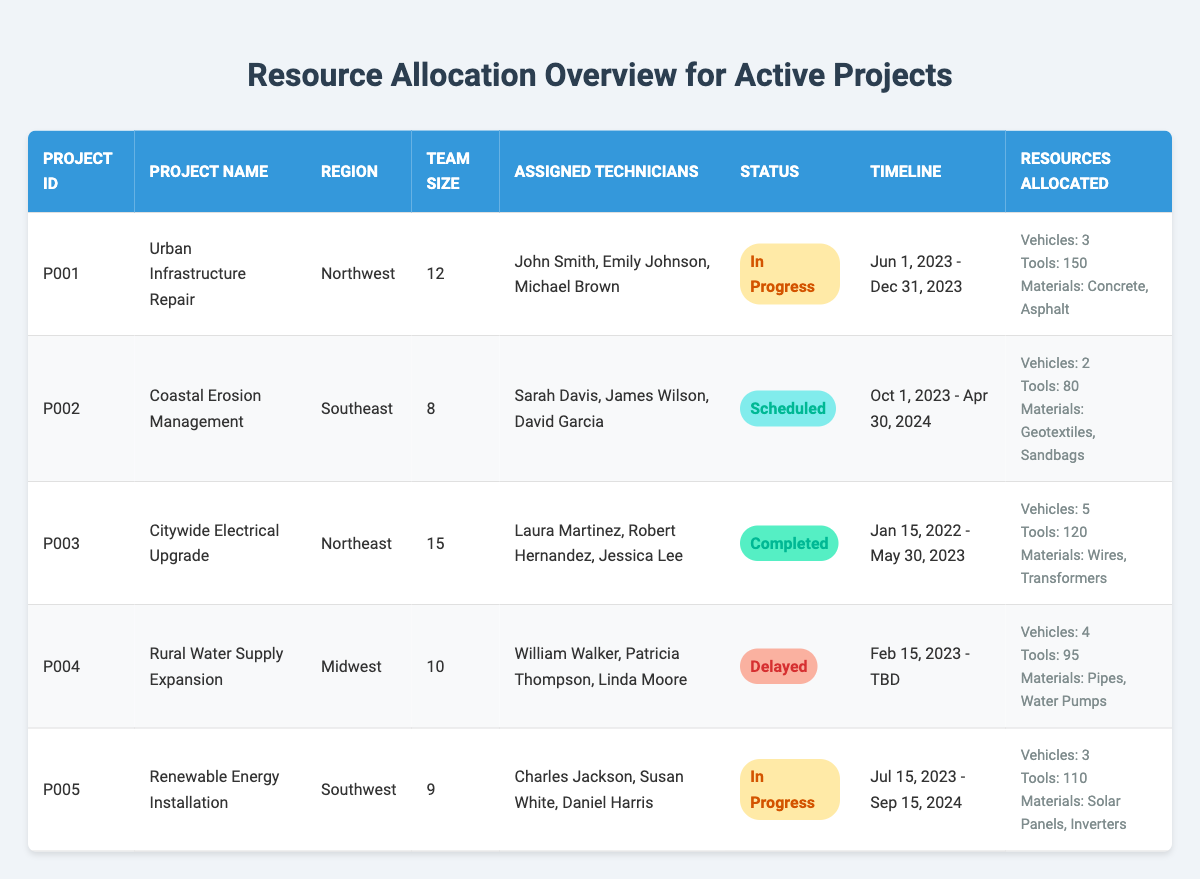What is the project name for ID P002? By looking at the table, I can find the row where the Project ID is P002, which corresponds to the project name "Coastal Erosion Management."
Answer: Coastal Erosion Management How many vehicles are allocated to the "Urban Infrastructure Repair" project? The project with the name "Urban Infrastructure Repair" has 3 vehicles allocated, as indicated in the resources allocated section of the respective row.
Answer: 3 Which project has the largest team size? To determine the largest team size, I compare the team sizes listed for all projects. The largest team size is 15, which belongs to the "Citywide Electrical Upgrade" project.
Answer: 15 Is the "Rural Water Supply Expansion" project currently delayed? The status for the project "Rural Water Supply Expansion" indicates it is "Delayed," confirming that the project is not on schedule.
Answer: Yes What materials are allocated for the "Renewable Energy Installation" project? Looking at the resources allocated for the "Renewable Energy Installation" project, the materials listed are "Solar Panels, Inverters."
Answer: Solar Panels, Inverters How many total tools are allocated across all projects? I can add up the number of tools from each project: 150 (Urban Infrastructure Repair) + 80 (Coastal Erosion Management) + 120 (Citywide Electrical Upgrade) + 95 (Rural Water Supply Expansion) + 110 (Renewable Energy Installation) = 655 tools in total.
Answer: 655 Which project is scheduled to end first? Analyzing the end dates of all active projects, "Coastal Erosion Management" ends on April 30, 2024, while other projects end later, making this the earliest end date.
Answer: Coastal Erosion Management How many projects are currently in progress? Reviewing the project statuses, I find two projects: "Urban Infrastructure Repair" and "Renewable Energy Installation" are marked as "In Progress."
Answer: 2 What percentage of technicians are assigned to the "Citywide Electrical Upgrade" project from the total team sizes of all projects? The total team sizes from all projects add up to 54 (12 + 8 + 15 + 10 + 9). The Citywide Electrical Upgrade has 15 technicians. To find the percentage: (15/54) * 100 ≈ 27.78%.
Answer: ~27.78% If "Rural Water Supply Expansion" gets back on schedule, when will it likely end? The end date is marked "TBD," but the project started on February 15, 2023. The nature of such projects typically means they would take a similar duration as others. Assuming it follows a similar timeline to the average (approx. 6-12 months), it could likely end sometime late in 2024.
Answer: Late 2024 